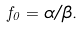<formula> <loc_0><loc_0><loc_500><loc_500>f _ { 0 } = \alpha / \beta .</formula> 